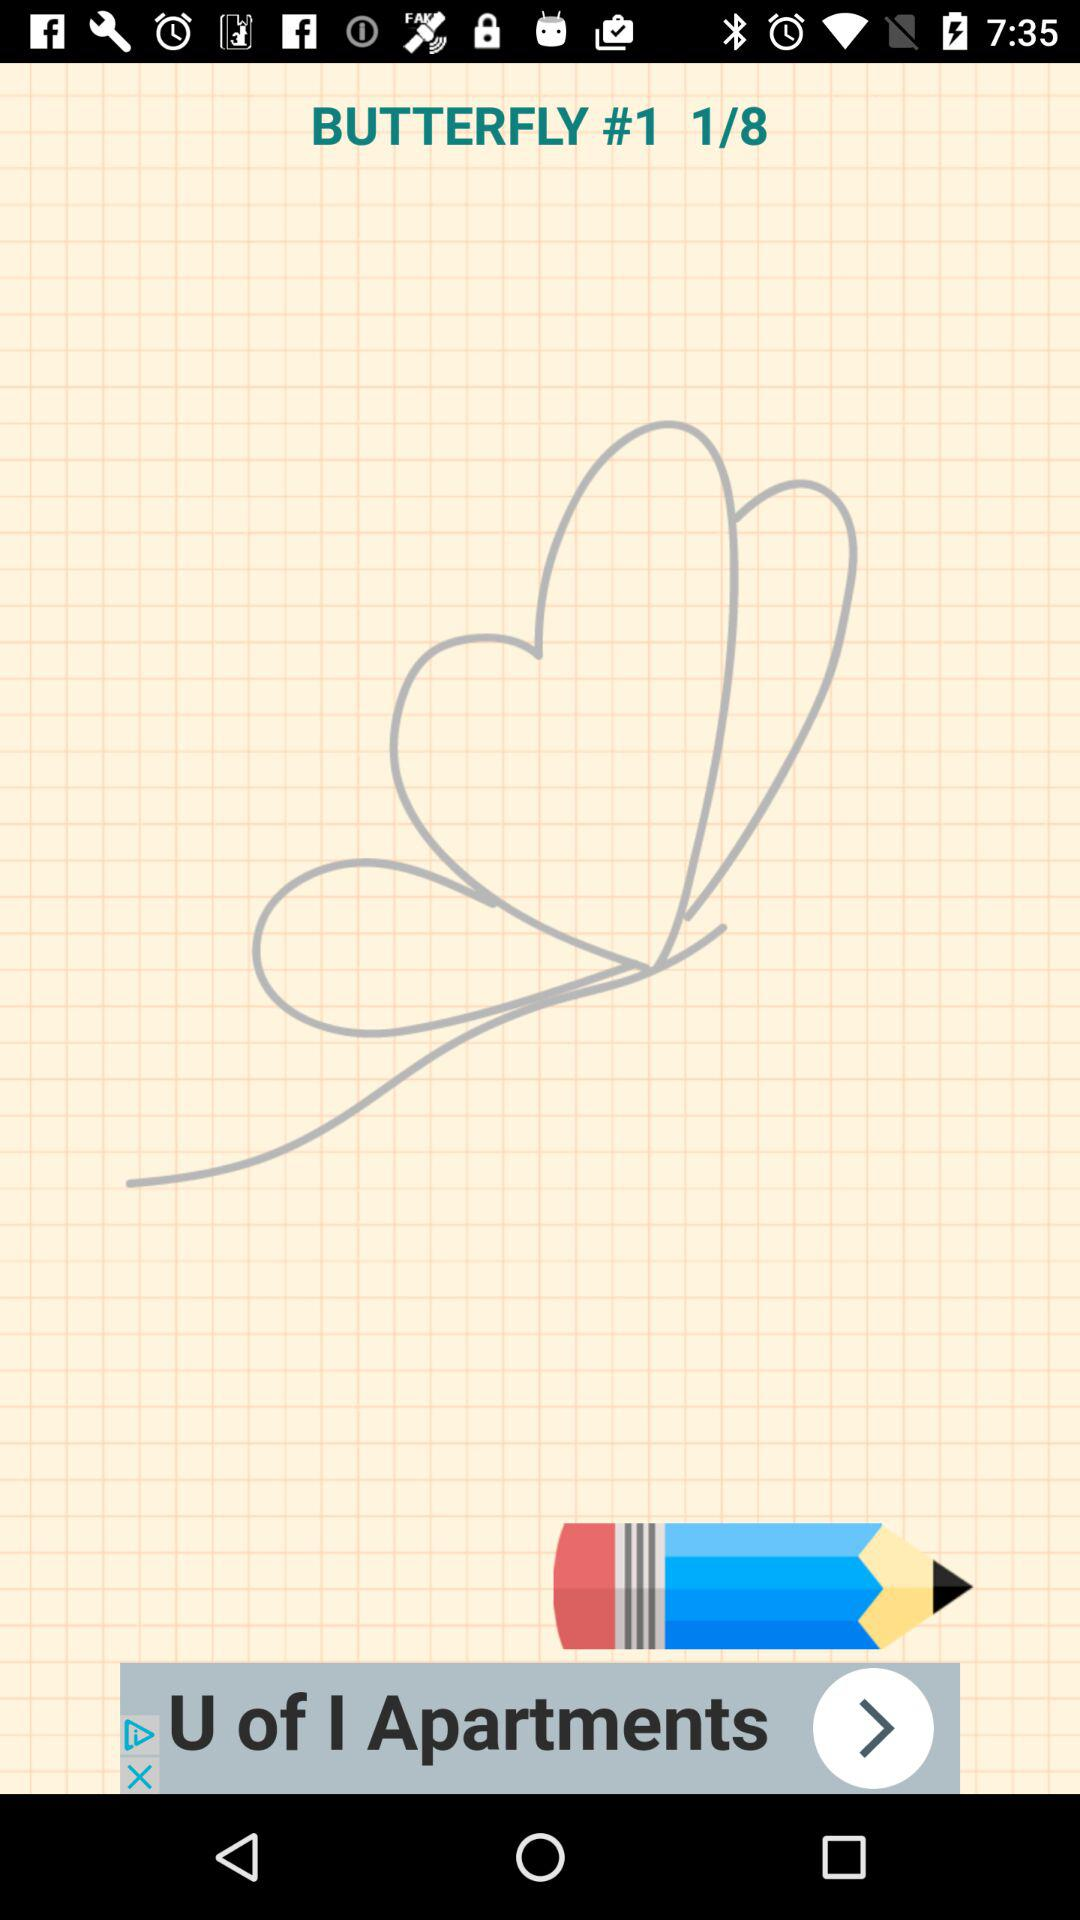What's the application's name?
When the provided information is insufficient, respond with <no answer>. <no answer> 